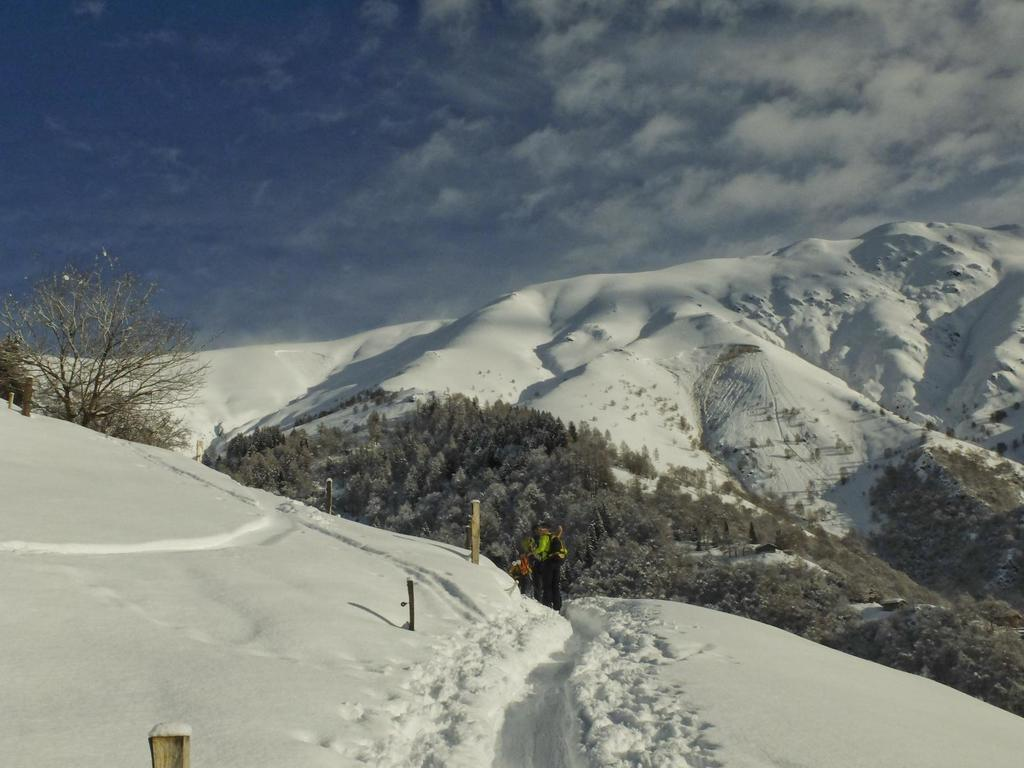Who or what is present in the image? There are people in the image. What is the surface on which the people are standing? The people are on the snow. What can be seen in the background of the image? There are trees and clouds visible in the background of the image. Where is the mom in the image? There is no mention of a mom in the image, so we cannot determine her location. 